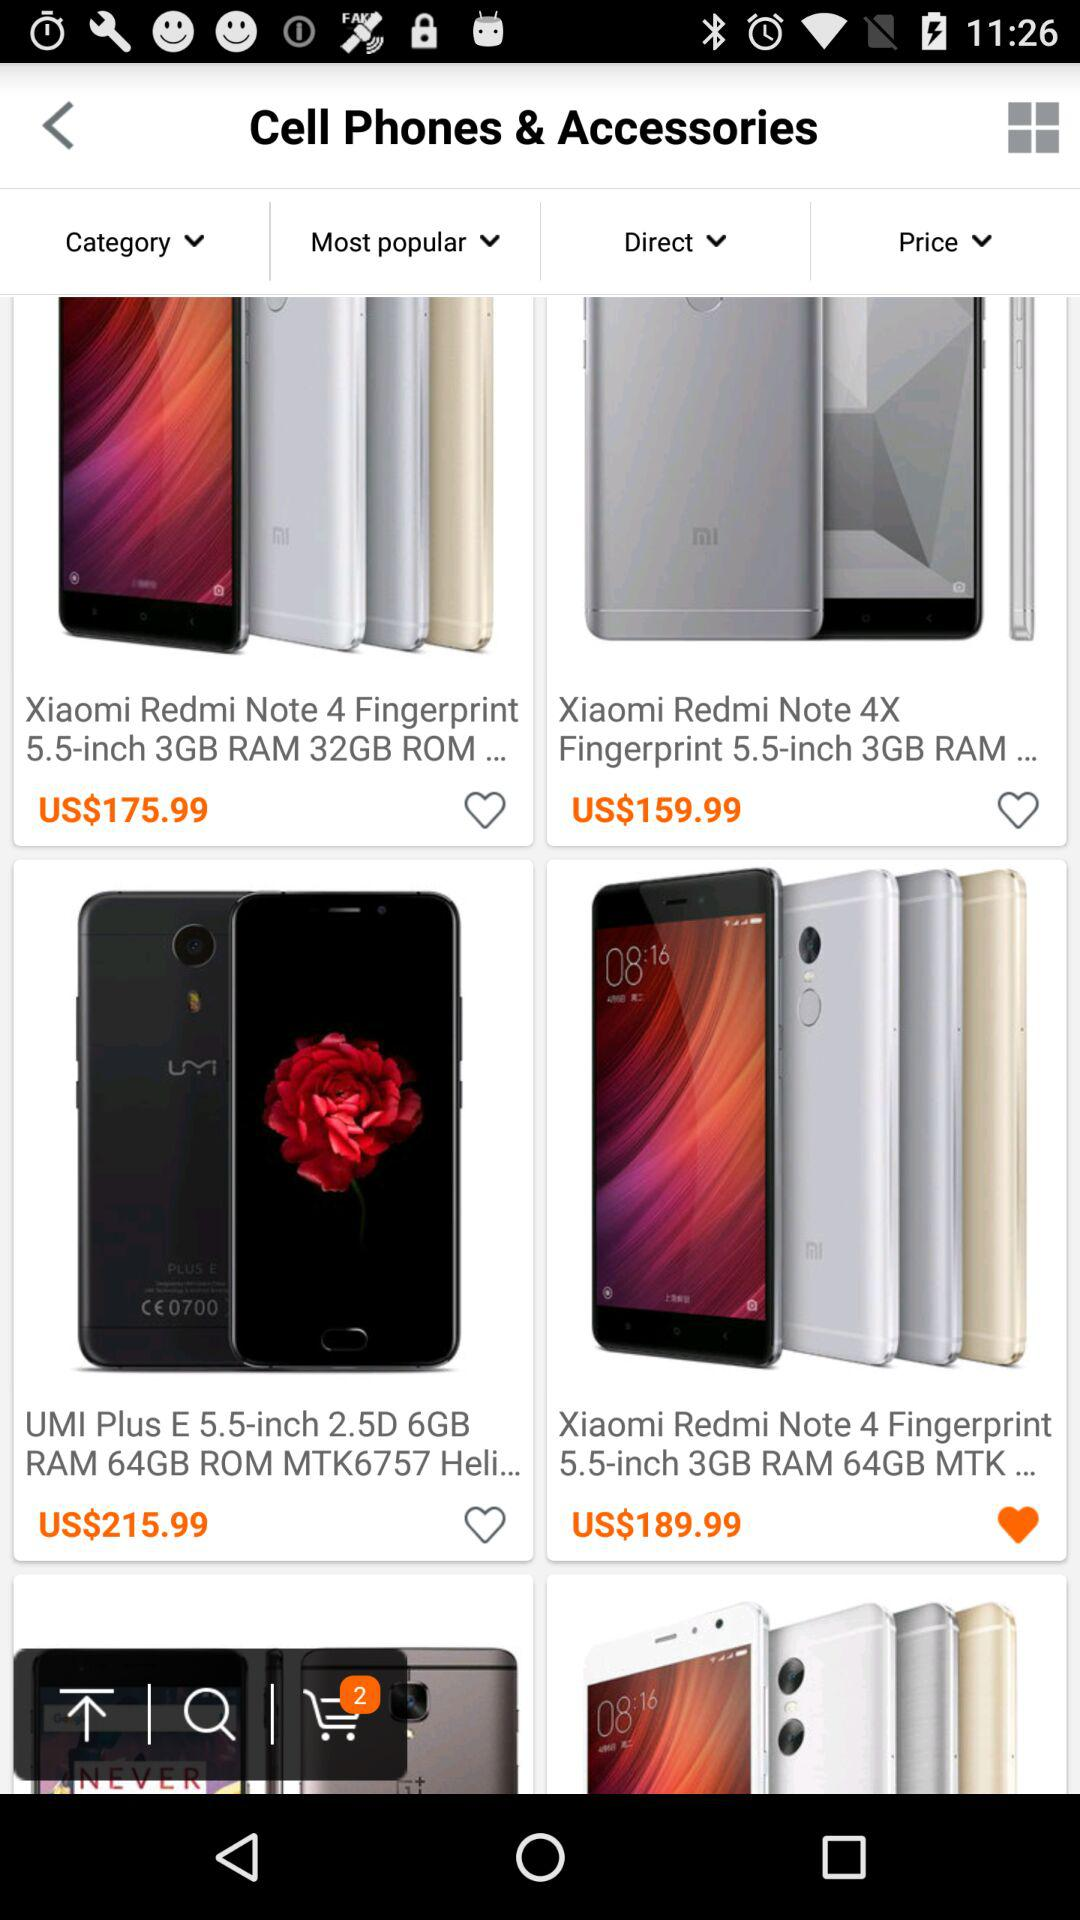What is the price of the phone that I liked? The price of the phone that you liked is 189.99 United States dollars. 